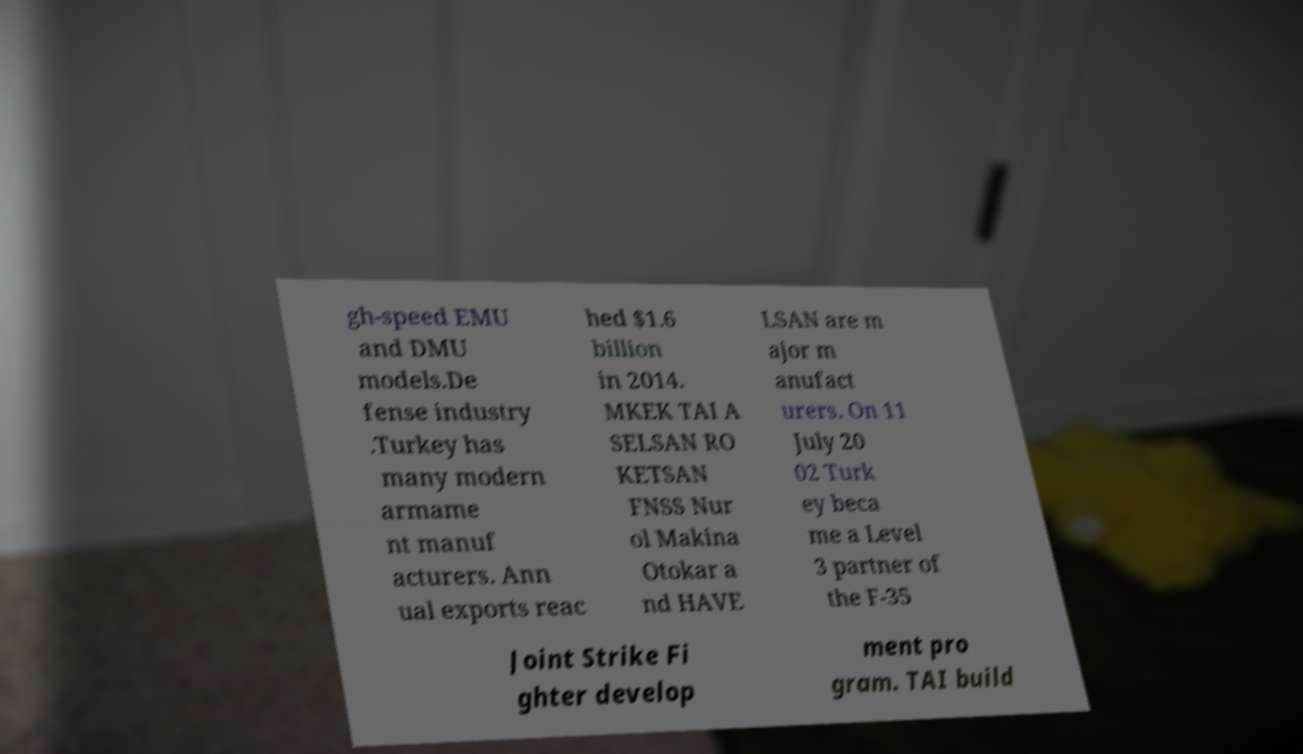Can you accurately transcribe the text from the provided image for me? gh-speed EMU and DMU models.De fense industry .Turkey has many modern armame nt manuf acturers. Ann ual exports reac hed $1.6 billion in 2014. MKEK TAI A SELSAN RO KETSAN FNSS Nur ol Makina Otokar a nd HAVE LSAN are m ajor m anufact urers. On 11 July 20 02 Turk ey beca me a Level 3 partner of the F-35 Joint Strike Fi ghter develop ment pro gram. TAI build 